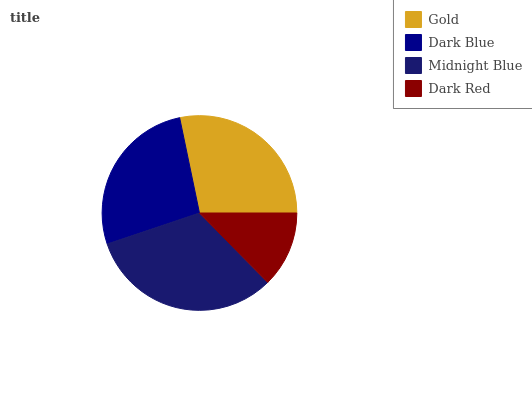Is Dark Red the minimum?
Answer yes or no. Yes. Is Midnight Blue the maximum?
Answer yes or no. Yes. Is Dark Blue the minimum?
Answer yes or no. No. Is Dark Blue the maximum?
Answer yes or no. No. Is Gold greater than Dark Blue?
Answer yes or no. Yes. Is Dark Blue less than Gold?
Answer yes or no. Yes. Is Dark Blue greater than Gold?
Answer yes or no. No. Is Gold less than Dark Blue?
Answer yes or no. No. Is Gold the high median?
Answer yes or no. Yes. Is Dark Blue the low median?
Answer yes or no. Yes. Is Midnight Blue the high median?
Answer yes or no. No. Is Midnight Blue the low median?
Answer yes or no. No. 